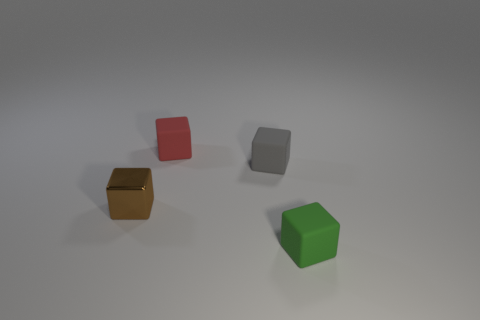Is the number of tiny metallic objects greater than the number of rubber objects?
Make the answer very short. No. There is a small thing in front of the tiny object that is to the left of the red rubber block; what is it made of?
Provide a short and direct response. Rubber. Is there a red matte cube that is left of the cube to the left of the red cube?
Your answer should be very brief. No. What number of small gray rubber things are left of the tiny matte block that is in front of the block that is to the left of the red rubber block?
Offer a very short reply. 1. What is the size of the matte thing in front of the object on the left side of the red cube?
Your answer should be very brief. Small. How many tiny green cubes are the same material as the brown cube?
Provide a short and direct response. 0. Are there any small purple shiny things?
Your answer should be very brief. No. What is the size of the thing in front of the brown metallic cube?
Offer a very short reply. Small. What number of cylinders are either big yellow metallic things or red things?
Offer a very short reply. 0. Are there any green rubber things of the same size as the metal thing?
Your answer should be compact. Yes. 